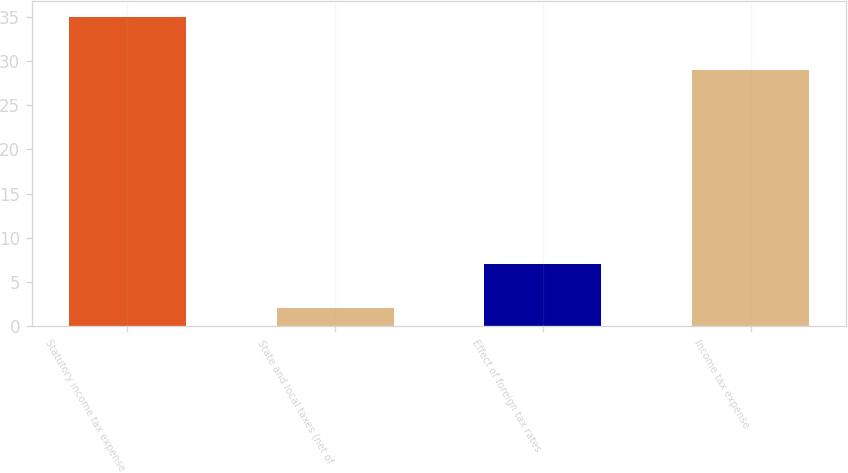Convert chart. <chart><loc_0><loc_0><loc_500><loc_500><bar_chart><fcel>Statutory income tax expense<fcel>State and local taxes (net of<fcel>Effect of foreign tax rates<fcel>Income tax expense<nl><fcel>35<fcel>2<fcel>7<fcel>29<nl></chart> 